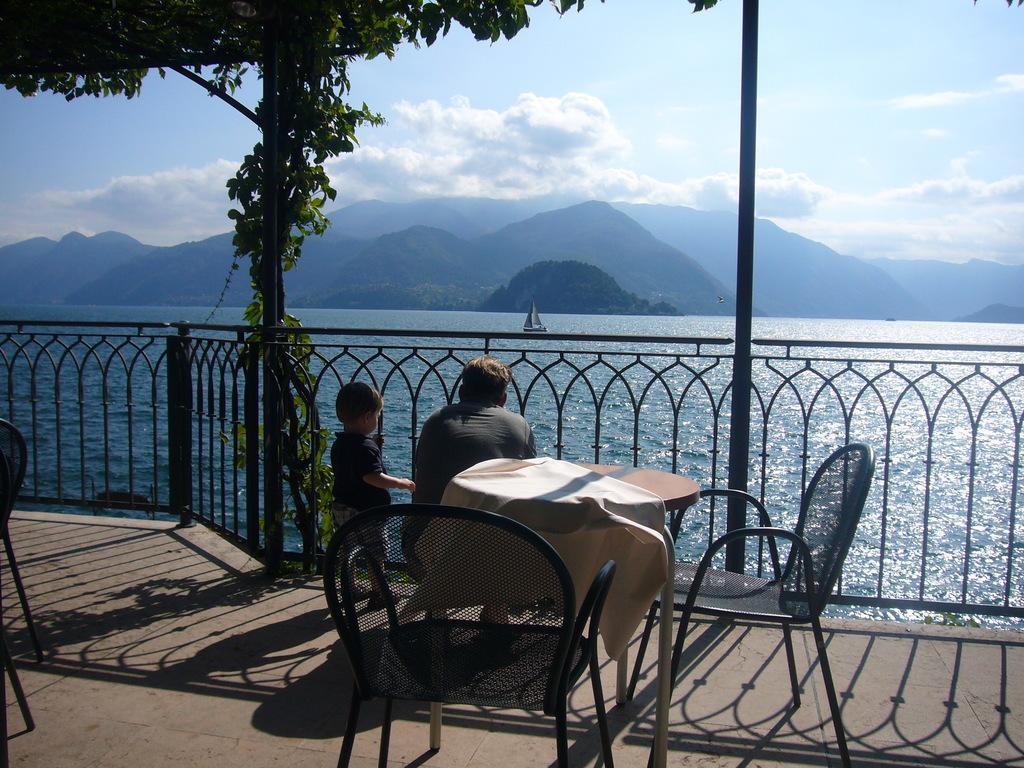In one or two sentences, can you explain what this image depicts? In the image we can see there is a man who is sitting on floor and beside him there is a boy who is standing. In Front of them there is an ocean and behind them there is table and chair and there is a clear sky. 